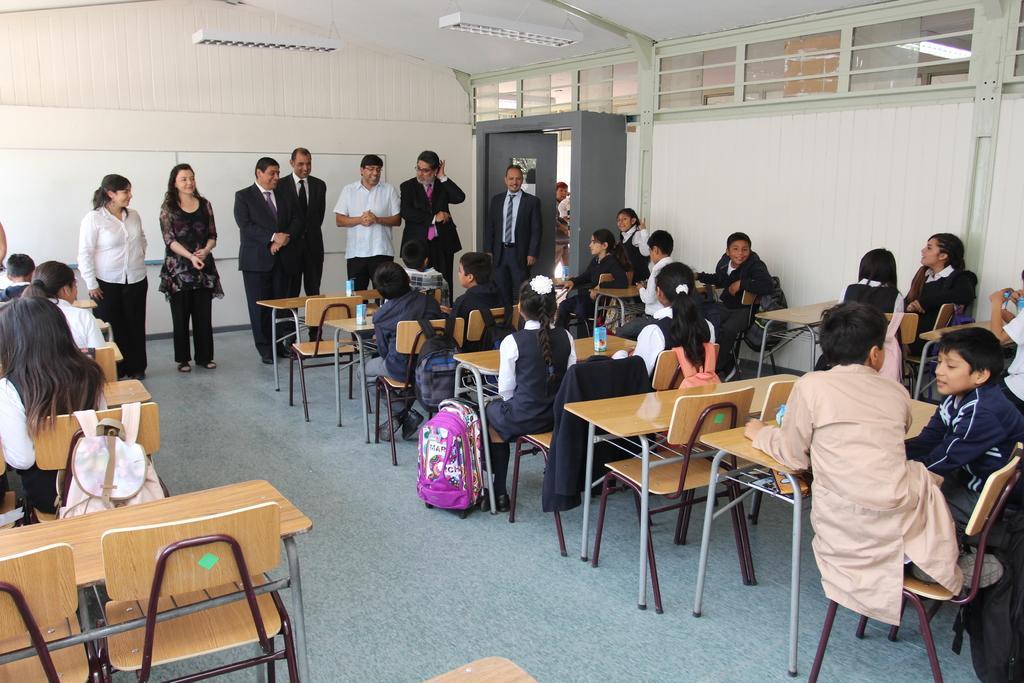Describe this image in one or two sentences. In this image I can see number of people where few are standing and rest all are sitting on chairs. I can see few of them are wearing formal dress and rest all are wearing school uniforms. I can also see few bags and few bottles. 